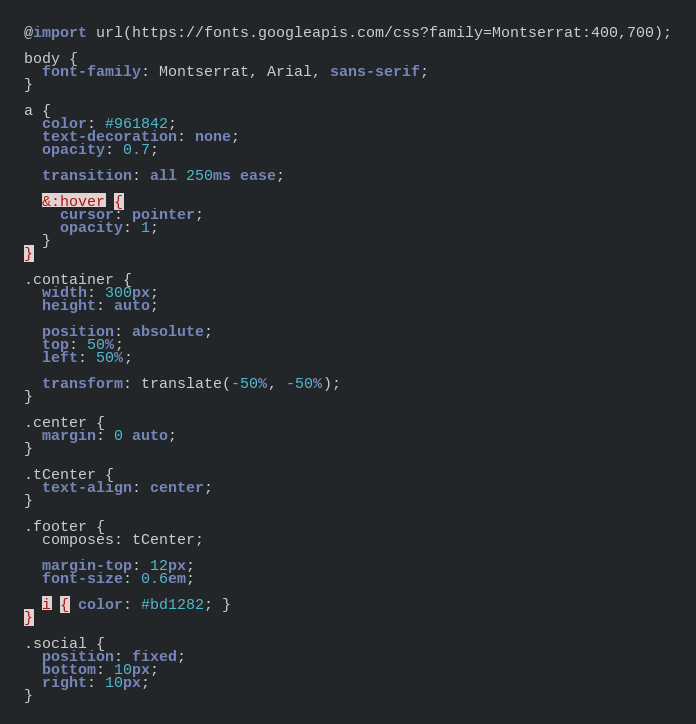Convert code to text. <code><loc_0><loc_0><loc_500><loc_500><_CSS_>@import url(https://fonts.googleapis.com/css?family=Montserrat:400,700);

body {
  font-family: Montserrat, Arial, sans-serif;
}

a {
  color: #961842;
  text-decoration: none;
  opacity: 0.7;

  transition: all 250ms ease;

  &:hover {
    cursor: pointer;
    opacity: 1;
  }
}

.container {
  width: 300px;
  height: auto;

  position: absolute;
  top: 50%;
  left: 50%;

  transform: translate(-50%, -50%);
}

.center {
  margin: 0 auto;
}

.tCenter {
  text-align: center;
}

.footer {
  composes: tCenter;

  margin-top: 12px;
  font-size: 0.6em;

  i { color: #bd1282; }
}

.social {
  position: fixed;
  bottom: 10px;
  right: 10px;
}
</code> 